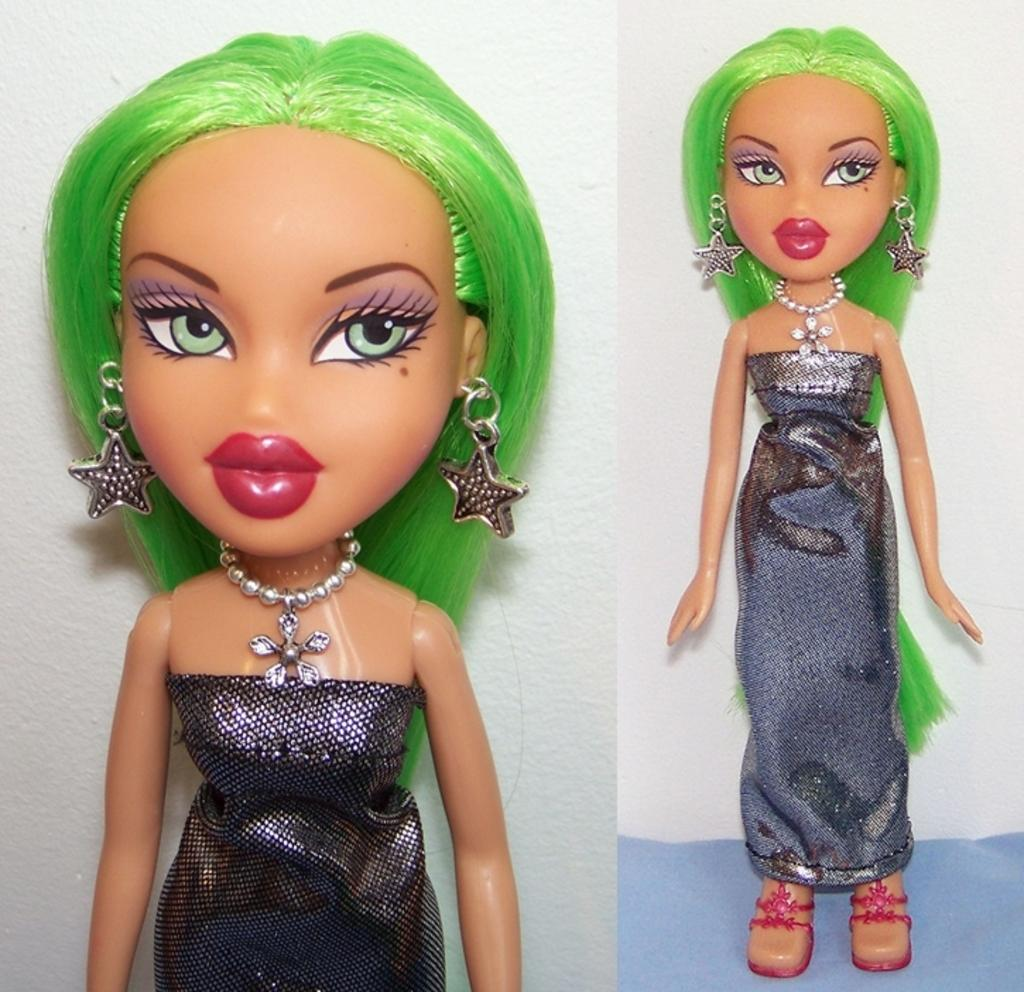What is the main subject in the image? There is a doll in the image. Can you describe the background of the image? There is a wall in the background of the image. What type of throne is the doll sitting on in the image? There is no throne present in the image; the doll is not sitting on anything. 